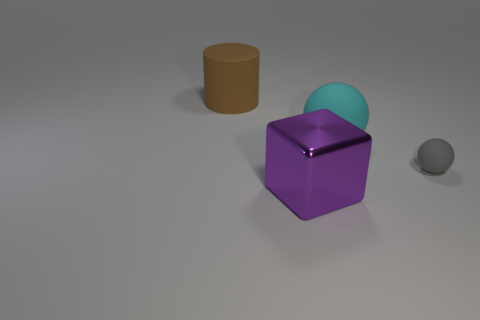There is a matte thing to the left of the purple metal object; does it have the same size as the tiny gray sphere?
Keep it short and to the point. No. What is the color of the large matte thing that is on the right side of the big matte object that is to the left of the large thing on the right side of the big shiny thing?
Make the answer very short. Cyan. What color is the cylinder?
Offer a very short reply. Brown. Is the color of the big matte cylinder the same as the metallic thing?
Your answer should be compact. No. Are the ball that is in front of the cyan rubber object and the object in front of the gray rubber thing made of the same material?
Give a very brief answer. No. There is another small object that is the same shape as the cyan thing; what material is it?
Keep it short and to the point. Rubber. Is the large brown cylinder made of the same material as the big sphere?
Make the answer very short. Yes. The large matte thing on the left side of the rubber ball that is behind the tiny gray rubber thing is what color?
Give a very brief answer. Brown. There is a cylinder that is made of the same material as the tiny gray object; what size is it?
Make the answer very short. Large. How many other large matte objects have the same shape as the big purple object?
Provide a succinct answer. 0. 